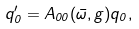Convert formula to latex. <formula><loc_0><loc_0><loc_500><loc_500>q ^ { \prime } _ { 0 } = A _ { 0 0 } ( \bar { \omega } , g ) q _ { 0 } ,</formula> 